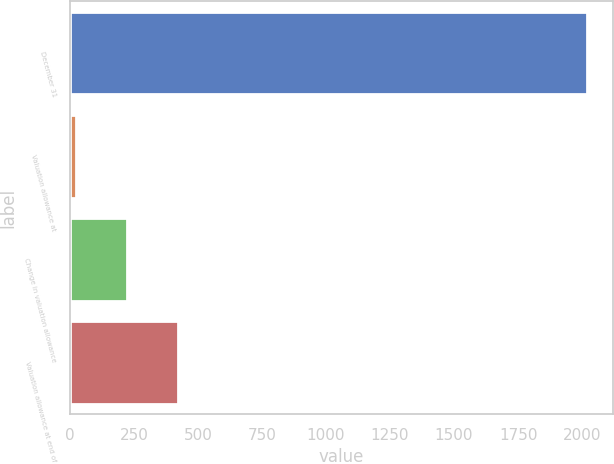Convert chart to OTSL. <chart><loc_0><loc_0><loc_500><loc_500><bar_chart><fcel>December 31<fcel>Valuation allowance at<fcel>Change in valuation allowance<fcel>Valuation allowance at end of<nl><fcel>2018<fcel>24<fcel>223.4<fcel>422.8<nl></chart> 